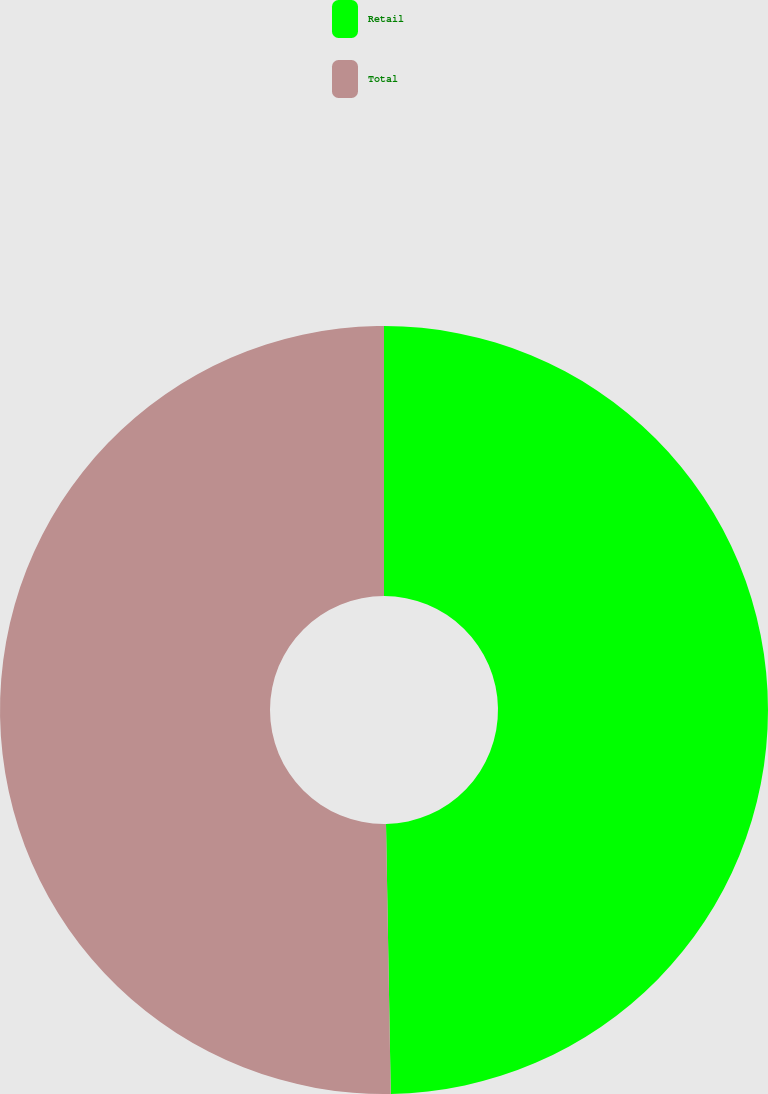Convert chart to OTSL. <chart><loc_0><loc_0><loc_500><loc_500><pie_chart><fcel>Retail<fcel>Total<nl><fcel>49.72%<fcel>50.28%<nl></chart> 